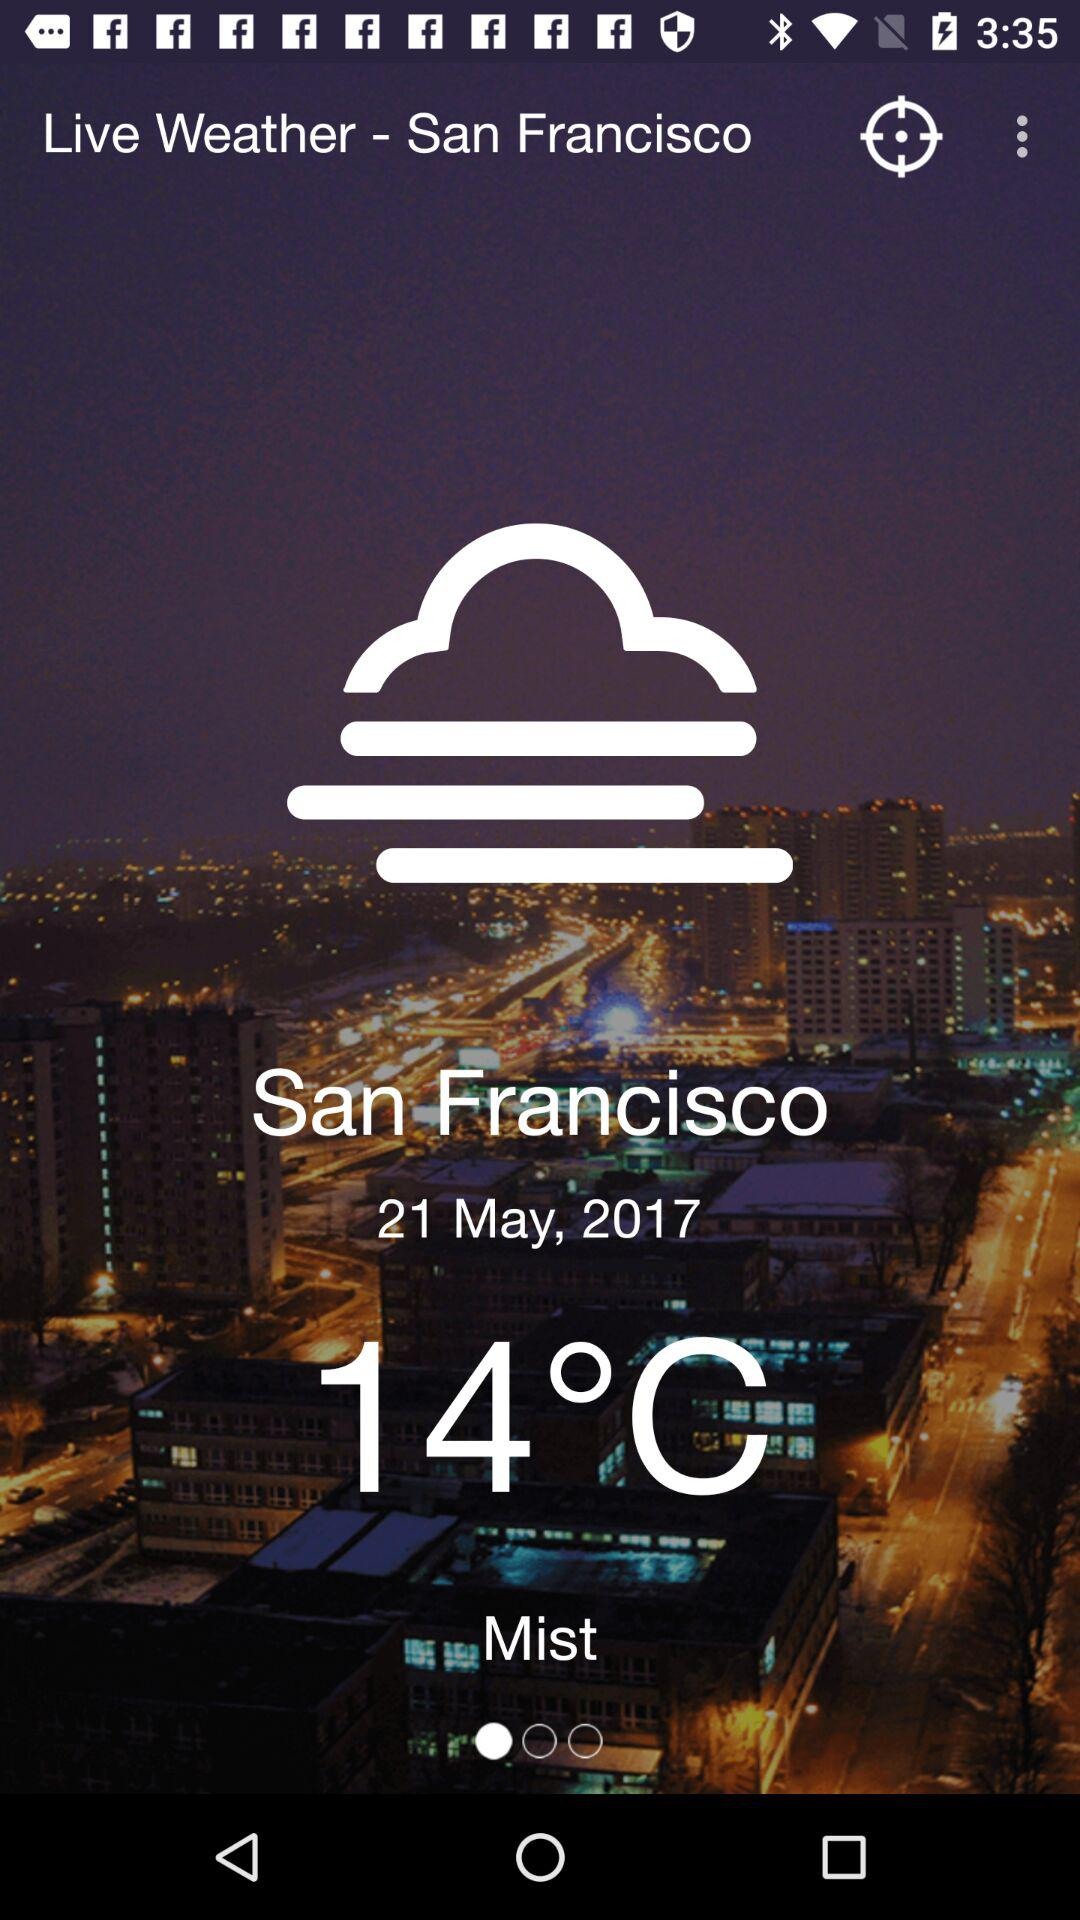What is the date for which the weather is given? The date is May 21, 2017. 